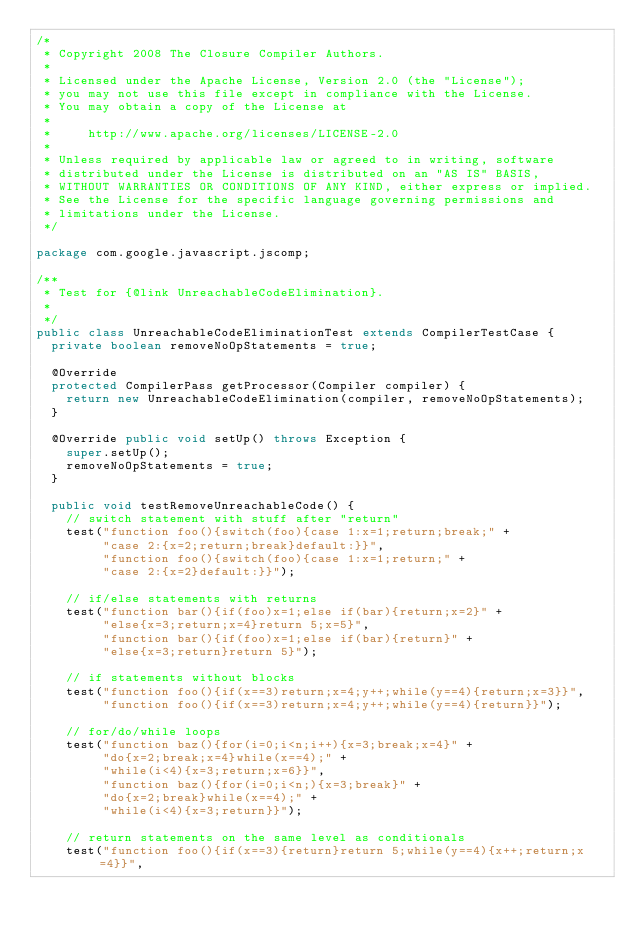<code> <loc_0><loc_0><loc_500><loc_500><_Java_>/*
 * Copyright 2008 The Closure Compiler Authors.
 *
 * Licensed under the Apache License, Version 2.0 (the "License");
 * you may not use this file except in compliance with the License.
 * You may obtain a copy of the License at
 *
 *     http://www.apache.org/licenses/LICENSE-2.0
 *
 * Unless required by applicable law or agreed to in writing, software
 * distributed under the License is distributed on an "AS IS" BASIS,
 * WITHOUT WARRANTIES OR CONDITIONS OF ANY KIND, either express or implied.
 * See the License for the specific language governing permissions and
 * limitations under the License.
 */

package com.google.javascript.jscomp;

/**
 * Test for {@link UnreachableCodeElimination}.
 *
 */
public class UnreachableCodeEliminationTest extends CompilerTestCase {
  private boolean removeNoOpStatements = true;

  @Override
  protected CompilerPass getProcessor(Compiler compiler) {
    return new UnreachableCodeElimination(compiler, removeNoOpStatements);
  }

  @Override public void setUp() throws Exception {
    super.setUp();
    removeNoOpStatements = true;
  }

  public void testRemoveUnreachableCode() {
    // switch statement with stuff after "return"
    test("function foo(){switch(foo){case 1:x=1;return;break;" +
         "case 2:{x=2;return;break}default:}}",
         "function foo(){switch(foo){case 1:x=1;return;" +
         "case 2:{x=2}default:}}");

    // if/else statements with returns
    test("function bar(){if(foo)x=1;else if(bar){return;x=2}" +
         "else{x=3;return;x=4}return 5;x=5}",
         "function bar(){if(foo)x=1;else if(bar){return}" +
         "else{x=3;return}return 5}");

    // if statements without blocks
    test("function foo(){if(x==3)return;x=4;y++;while(y==4){return;x=3}}",
         "function foo(){if(x==3)return;x=4;y++;while(y==4){return}}");

    // for/do/while loops
    test("function baz(){for(i=0;i<n;i++){x=3;break;x=4}" +
         "do{x=2;break;x=4}while(x==4);" +
         "while(i<4){x=3;return;x=6}}",
         "function baz(){for(i=0;i<n;){x=3;break}" +
         "do{x=2;break}while(x==4);" +
         "while(i<4){x=3;return}}");

    // return statements on the same level as conditionals
    test("function foo(){if(x==3){return}return 5;while(y==4){x++;return;x=4}}",</code> 